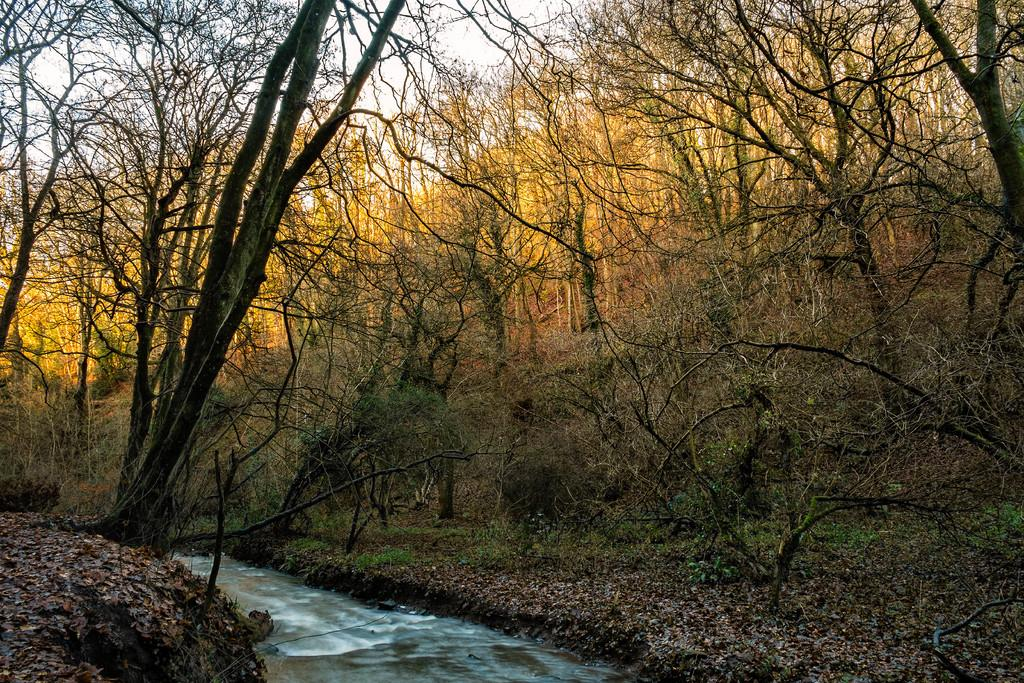What is the main subject in the center of the image? There is water in the center of the image. What can be seen on both sides of the water? There are trees on both sides of the water. What is visible in the background of the image? The sky is visible in the background of the image. Can you see any cherries growing on the trees in the image? There is no mention of cherries or any fruit trees in the image; it only features water and trees. 